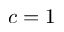<formula> <loc_0><loc_0><loc_500><loc_500>{ c = 1 }</formula> 